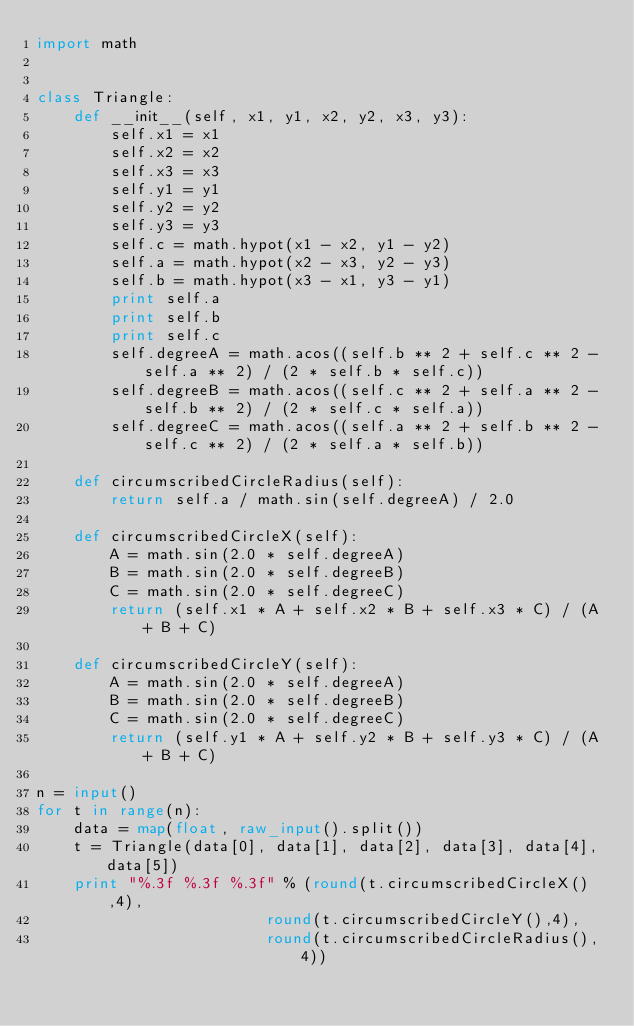<code> <loc_0><loc_0><loc_500><loc_500><_Python_>import math


class Triangle:
    def __init__(self, x1, y1, x2, y2, x3, y3):
        self.x1 = x1
        self.x2 = x2
        self.x3 = x3
        self.y1 = y1
        self.y2 = y2
        self.y3 = y3
        self.c = math.hypot(x1 - x2, y1 - y2)
        self.a = math.hypot(x2 - x3, y2 - y3)
        self.b = math.hypot(x3 - x1, y3 - y1)
        print self.a
        print self.b
        print self.c
        self.degreeA = math.acos((self.b ** 2 + self.c ** 2 - self.a ** 2) / (2 * self.b * self.c))
        self.degreeB = math.acos((self.c ** 2 + self.a ** 2 - self.b ** 2) / (2 * self.c * self.a))
        self.degreeC = math.acos((self.a ** 2 + self.b ** 2 - self.c ** 2) / (2 * self.a * self.b))

    def circumscribedCircleRadius(self):
        return self.a / math.sin(self.degreeA) / 2.0

    def circumscribedCircleX(self):
        A = math.sin(2.0 * self.degreeA)
        B = math.sin(2.0 * self.degreeB)
        C = math.sin(2.0 * self.degreeC)
        return (self.x1 * A + self.x2 * B + self.x3 * C) / (A + B + C)

    def circumscribedCircleY(self):
        A = math.sin(2.0 * self.degreeA)
        B = math.sin(2.0 * self.degreeB)
        C = math.sin(2.0 * self.degreeC)
        return (self.y1 * A + self.y2 * B + self.y3 * C) / (A + B + C)
    
n = input()
for t in range(n):
    data = map(float, raw_input().split())
    t = Triangle(data[0], data[1], data[2], data[3], data[4], data[5])
    print "%.3f %.3f %.3f" % (round(t.circumscribedCircleX(),4),
                         round(t.circumscribedCircleY(),4),
                         round(t.circumscribedCircleRadius(), 4))</code> 